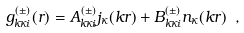Convert formula to latex. <formula><loc_0><loc_0><loc_500><loc_500>g ^ { ( \pm ) } _ { k \kappa i } ( r ) = A _ { k \kappa i } ^ { ( \pm ) } j _ { \kappa } ( k r ) + B _ { k \kappa i } ^ { ( \pm ) } n _ { \kappa } ( k r ) \ ,</formula> 